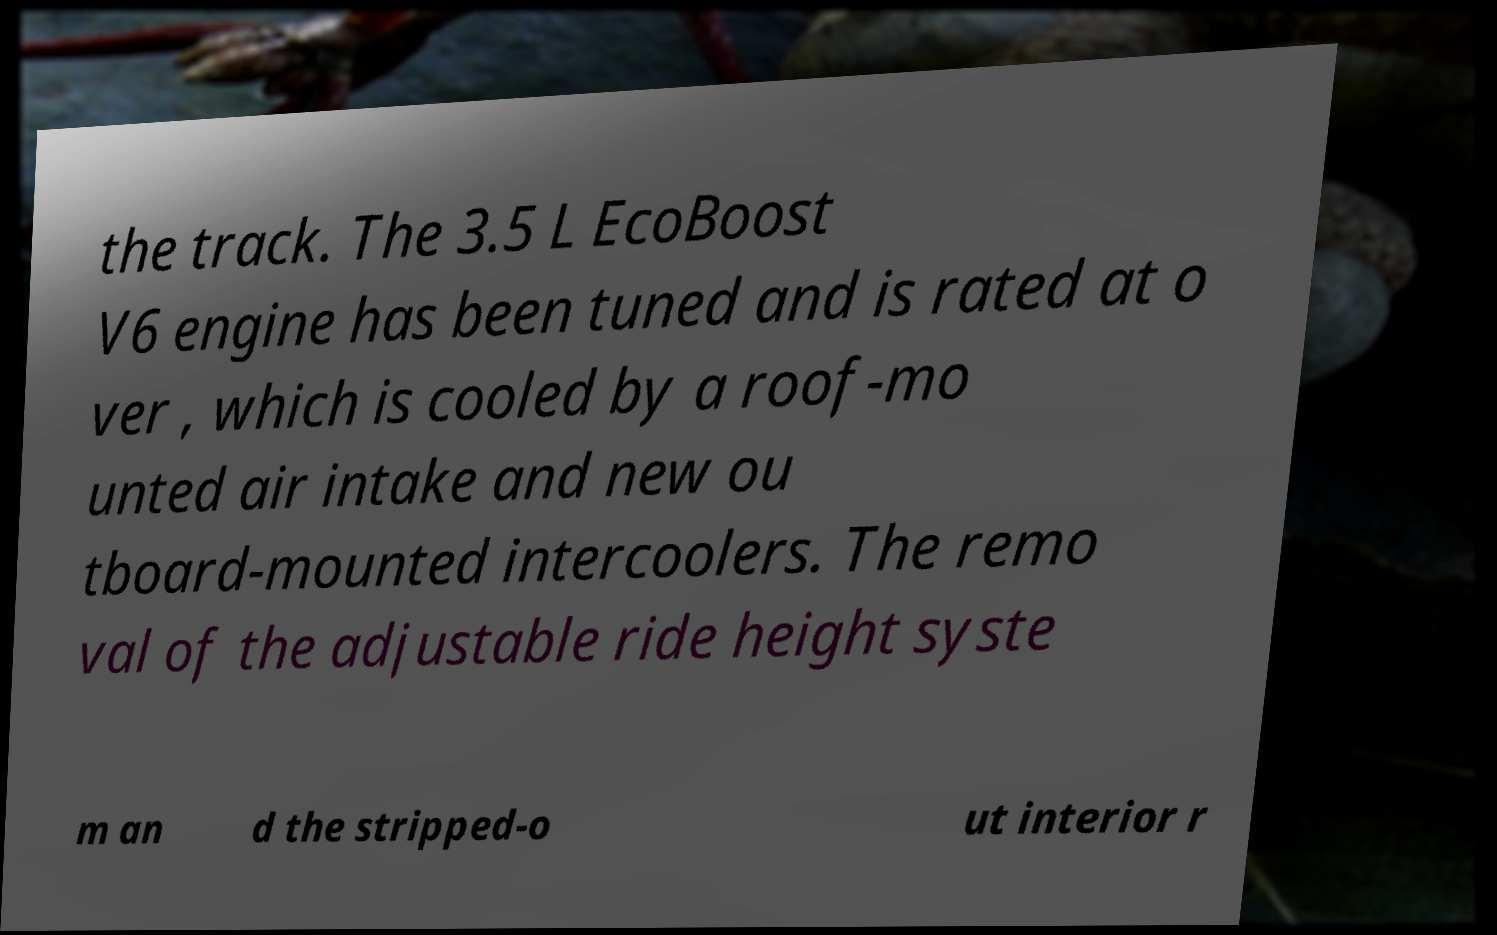Could you assist in decoding the text presented in this image and type it out clearly? the track. The 3.5 L EcoBoost V6 engine has been tuned and is rated at o ver , which is cooled by a roof-mo unted air intake and new ou tboard-mounted intercoolers. The remo val of the adjustable ride height syste m an d the stripped-o ut interior r 